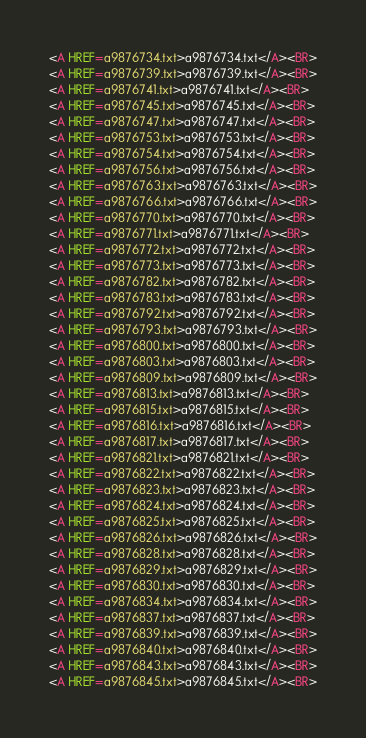Convert code to text. <code><loc_0><loc_0><loc_500><loc_500><_HTML_><A HREF=a9876734.txt>a9876734.txt</A><BR>
<A HREF=a9876739.txt>a9876739.txt</A><BR>
<A HREF=a9876741.txt>a9876741.txt</A><BR>
<A HREF=a9876745.txt>a9876745.txt</A><BR>
<A HREF=a9876747.txt>a9876747.txt</A><BR>
<A HREF=a9876753.txt>a9876753.txt</A><BR>
<A HREF=a9876754.txt>a9876754.txt</A><BR>
<A HREF=a9876756.txt>a9876756.txt</A><BR>
<A HREF=a9876763.txt>a9876763.txt</A><BR>
<A HREF=a9876766.txt>a9876766.txt</A><BR>
<A HREF=a9876770.txt>a9876770.txt</A><BR>
<A HREF=a9876771.txt>a9876771.txt</A><BR>
<A HREF=a9876772.txt>a9876772.txt</A><BR>
<A HREF=a9876773.txt>a9876773.txt</A><BR>
<A HREF=a9876782.txt>a9876782.txt</A><BR>
<A HREF=a9876783.txt>a9876783.txt</A><BR>
<A HREF=a9876792.txt>a9876792.txt</A><BR>
<A HREF=a9876793.txt>a9876793.txt</A><BR>
<A HREF=a9876800.txt>a9876800.txt</A><BR>
<A HREF=a9876803.txt>a9876803.txt</A><BR>
<A HREF=a9876809.txt>a9876809.txt</A><BR>
<A HREF=a9876813.txt>a9876813.txt</A><BR>
<A HREF=a9876815.txt>a9876815.txt</A><BR>
<A HREF=a9876816.txt>a9876816.txt</A><BR>
<A HREF=a9876817.txt>a9876817.txt</A><BR>
<A HREF=a9876821.txt>a9876821.txt</A><BR>
<A HREF=a9876822.txt>a9876822.txt</A><BR>
<A HREF=a9876823.txt>a9876823.txt</A><BR>
<A HREF=a9876824.txt>a9876824.txt</A><BR>
<A HREF=a9876825.txt>a9876825.txt</A><BR>
<A HREF=a9876826.txt>a9876826.txt</A><BR>
<A HREF=a9876828.txt>a9876828.txt</A><BR>
<A HREF=a9876829.txt>a9876829.txt</A><BR>
<A HREF=a9876830.txt>a9876830.txt</A><BR>
<A HREF=a9876834.txt>a9876834.txt</A><BR>
<A HREF=a9876837.txt>a9876837.txt</A><BR>
<A HREF=a9876839.txt>a9876839.txt</A><BR>
<A HREF=a9876840.txt>a9876840.txt</A><BR>
<A HREF=a9876843.txt>a9876843.txt</A><BR>
<A HREF=a9876845.txt>a9876845.txt</A><BR></code> 